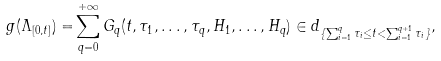Convert formula to latex. <formula><loc_0><loc_0><loc_500><loc_500>g ( \Lambda _ { [ 0 , t ] } ) = & \sum _ { q = 0 } ^ { + \infty } G _ { q } ( t , \tau _ { 1 } , \dots , \tau _ { q } , H _ { 1 } , \dots , H _ { q } ) \in d _ { \{ \sum _ { i = 1 } ^ { q } \tau _ { i } \leq t < \sum _ { i = 1 } ^ { q + 1 } \tau _ { i } \} } ,</formula> 